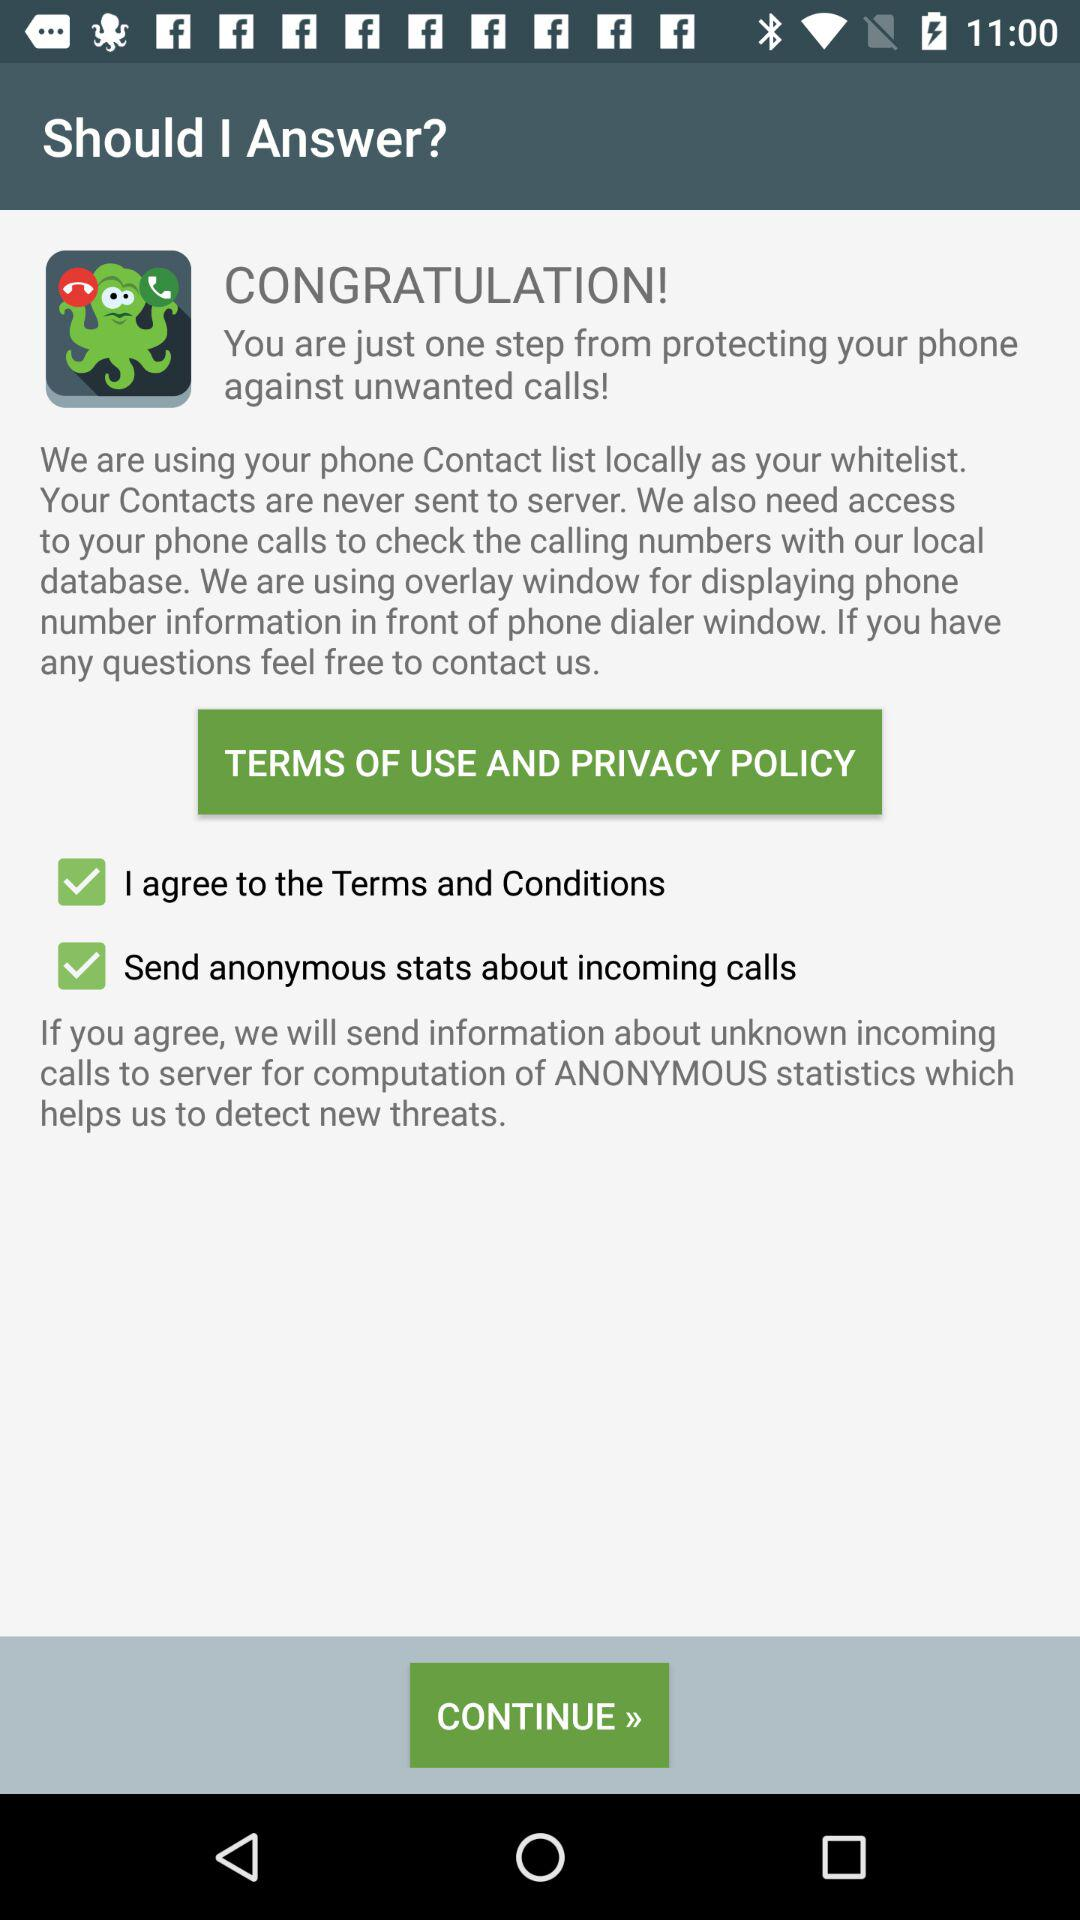What is the status of "Terms and Conditions"? The status is "on". 